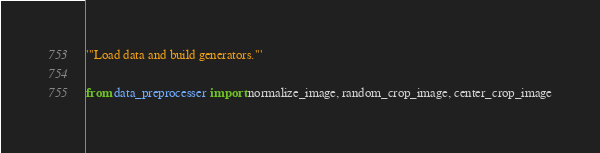Convert code to text. <code><loc_0><loc_0><loc_500><loc_500><_Python_>'''Load data and build generators.'''

from data_preprocesser import normalize_image, random_crop_image, center_crop_image</code> 